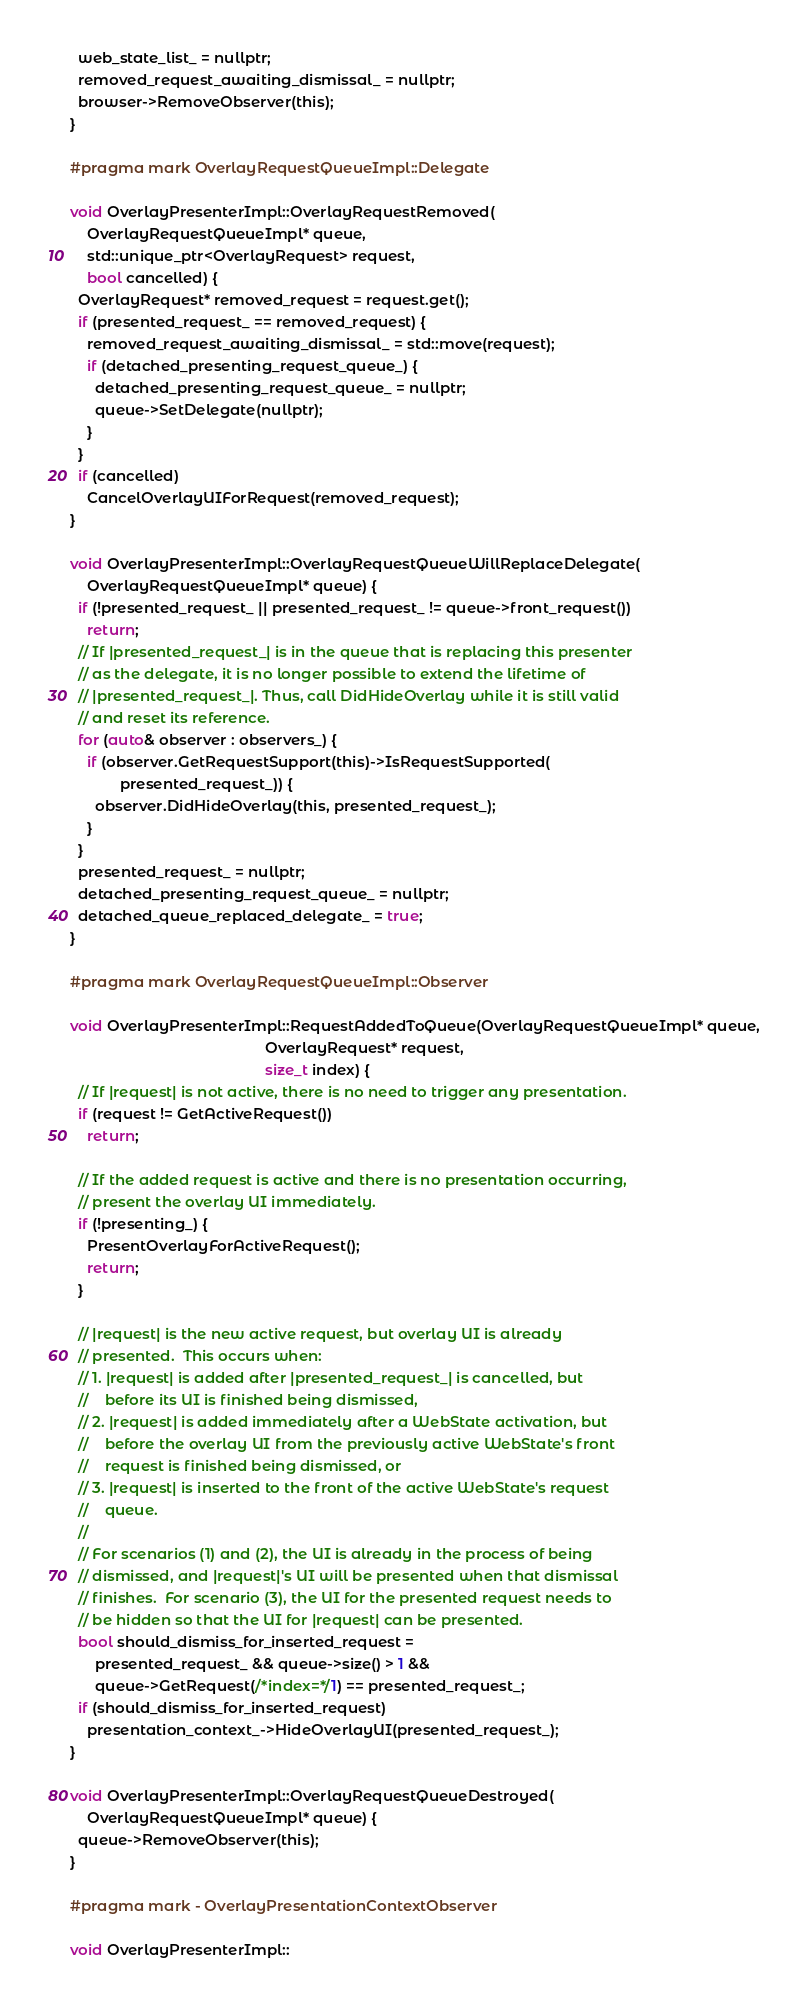<code> <loc_0><loc_0><loc_500><loc_500><_ObjectiveC_>  web_state_list_ = nullptr;
  removed_request_awaiting_dismissal_ = nullptr;
  browser->RemoveObserver(this);
}

#pragma mark OverlayRequestQueueImpl::Delegate

void OverlayPresenterImpl::OverlayRequestRemoved(
    OverlayRequestQueueImpl* queue,
    std::unique_ptr<OverlayRequest> request,
    bool cancelled) {
  OverlayRequest* removed_request = request.get();
  if (presented_request_ == removed_request) {
    removed_request_awaiting_dismissal_ = std::move(request);
    if (detached_presenting_request_queue_) {
      detached_presenting_request_queue_ = nullptr;
      queue->SetDelegate(nullptr);
    }
  }
  if (cancelled)
    CancelOverlayUIForRequest(removed_request);
}

void OverlayPresenterImpl::OverlayRequestQueueWillReplaceDelegate(
    OverlayRequestQueueImpl* queue) {
  if (!presented_request_ || presented_request_ != queue->front_request())
    return;
  // If |presented_request_| is in the queue that is replacing this presenter
  // as the delegate, it is no longer possible to extend the lifetime of
  // |presented_request_|. Thus, call DidHideOverlay while it is still valid
  // and reset its reference.
  for (auto& observer : observers_) {
    if (observer.GetRequestSupport(this)->IsRequestSupported(
            presented_request_)) {
      observer.DidHideOverlay(this, presented_request_);
    }
  }
  presented_request_ = nullptr;
  detached_presenting_request_queue_ = nullptr;
  detached_queue_replaced_delegate_ = true;
}

#pragma mark OverlayRequestQueueImpl::Observer

void OverlayPresenterImpl::RequestAddedToQueue(OverlayRequestQueueImpl* queue,
                                               OverlayRequest* request,
                                               size_t index) {
  // If |request| is not active, there is no need to trigger any presentation.
  if (request != GetActiveRequest())
    return;

  // If the added request is active and there is no presentation occurring,
  // present the overlay UI immediately.
  if (!presenting_) {
    PresentOverlayForActiveRequest();
    return;
  }

  // |request| is the new active request, but overlay UI is already
  // presented.  This occurs when:
  // 1. |request| is added after |presented_request_| is cancelled, but
  //    before its UI is finished being dismissed,
  // 2. |request| is added immediately after a WebState activation, but
  //    before the overlay UI from the previously active WebState's front
  //    request is finished being dismissed, or
  // 3. |request| is inserted to the front of the active WebState's request
  //    queue.
  //
  // For scenarios (1) and (2), the UI is already in the process of being
  // dismissed, and |request|'s UI will be presented when that dismissal
  // finishes.  For scenario (3), the UI for the presented request needs to
  // be hidden so that the UI for |request| can be presented.
  bool should_dismiss_for_inserted_request =
      presented_request_ && queue->size() > 1 &&
      queue->GetRequest(/*index=*/1) == presented_request_;
  if (should_dismiss_for_inserted_request)
    presentation_context_->HideOverlayUI(presented_request_);
}

void OverlayPresenterImpl::OverlayRequestQueueDestroyed(
    OverlayRequestQueueImpl* queue) {
  queue->RemoveObserver(this);
}

#pragma mark - OverlayPresentationContextObserver

void OverlayPresenterImpl::</code> 